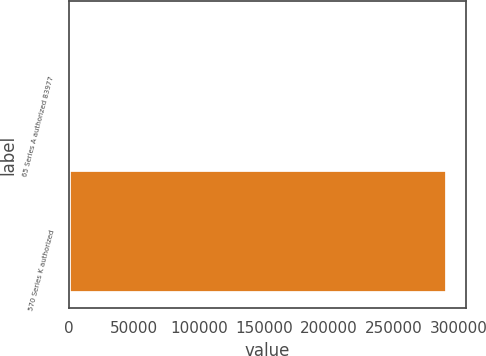Convert chart. <chart><loc_0><loc_0><loc_500><loc_500><bar_chart><fcel>65 Series A authorized 83977<fcel>570 Series K authorized<nl><fcel>1321<fcel>290971<nl></chart> 